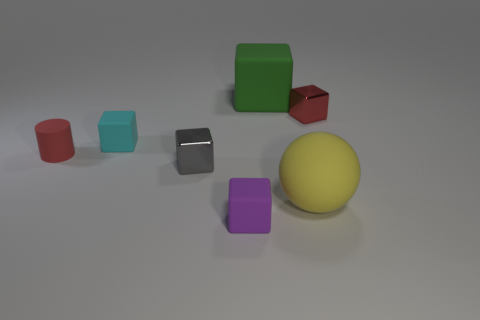There is a thing that is the same color as the small cylinder; what is it made of?
Provide a succinct answer. Metal. Are any purple metallic objects visible?
Offer a very short reply. No. What material is the tiny red object that is the same shape as the big green matte thing?
Provide a short and direct response. Metal. There is a small cyan matte block; are there any purple objects behind it?
Give a very brief answer. No. Are the large yellow sphere that is right of the cyan rubber cube and the cyan thing made of the same material?
Your answer should be compact. Yes. Are there any other rubber cylinders that have the same color as the tiny cylinder?
Offer a terse response. No. The big yellow object is what shape?
Your answer should be compact. Sphere. What color is the small metal thing that is behind the small metallic object that is to the left of the red block?
Make the answer very short. Red. How big is the red thing that is left of the purple cube?
Your answer should be compact. Small. Is there a tiny cube made of the same material as the big ball?
Make the answer very short. Yes. 